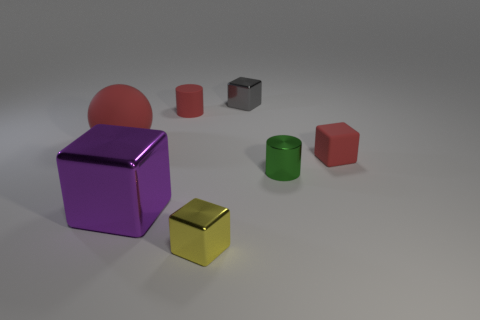What number of objects are big shiny blocks or green metal cylinders that are to the right of the large red rubber sphere?
Offer a terse response. 2. There is a small thing that is in front of the rubber cylinder and behind the green thing; what is its shape?
Your answer should be very brief. Cube. There is a small cylinder that is in front of the tiny red rubber thing that is on the left side of the small yellow metal block; what is its material?
Your response must be concise. Metal. Does the small block that is behind the big matte object have the same material as the green object?
Provide a short and direct response. Yes. What size is the red thing that is behind the red matte ball?
Give a very brief answer. Small. There is a small red matte object that is behind the matte ball; is there a small matte cylinder right of it?
Your answer should be compact. No. Does the tiny metal cube that is behind the tiny red matte cylinder have the same color as the shiny object left of the small matte cylinder?
Keep it short and to the point. No. What is the color of the large shiny block?
Your response must be concise. Purple. Is there any other thing that has the same color as the big metallic cube?
Offer a very short reply. No. What color is the metal block that is both in front of the small red rubber cylinder and right of the large purple shiny cube?
Provide a short and direct response. Yellow. 